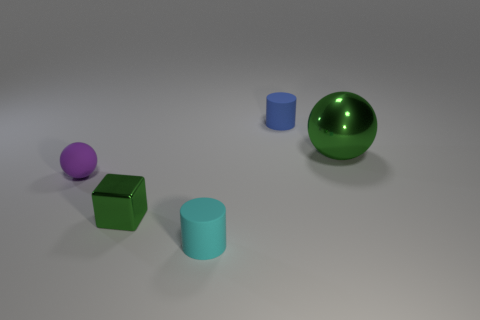Add 4 small gray shiny balls. How many objects exist? 9 Subtract all cylinders. How many objects are left? 3 Add 2 tiny purple rubber things. How many tiny purple rubber things are left? 3 Add 5 green blocks. How many green blocks exist? 6 Subtract 0 green cylinders. How many objects are left? 5 Subtract all cyan rubber things. Subtract all big blue balls. How many objects are left? 4 